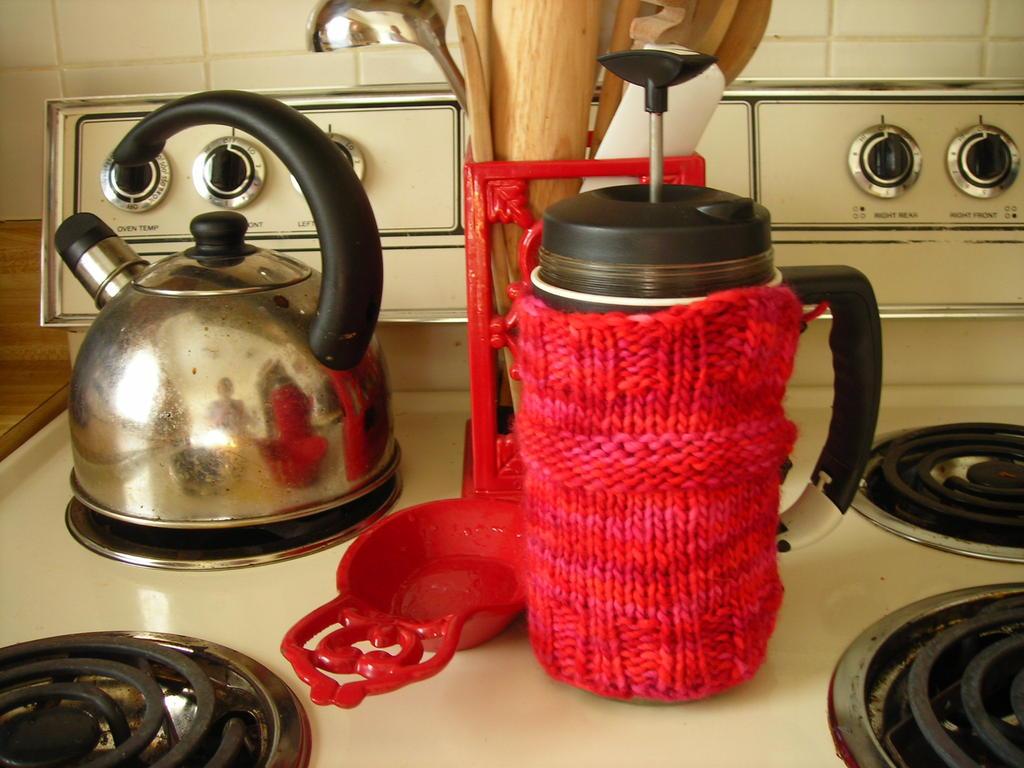How many stoves are there?
Keep it short and to the point. 4. How many pots are there?
Provide a short and direct response. Answering does not require reading text in the image. 